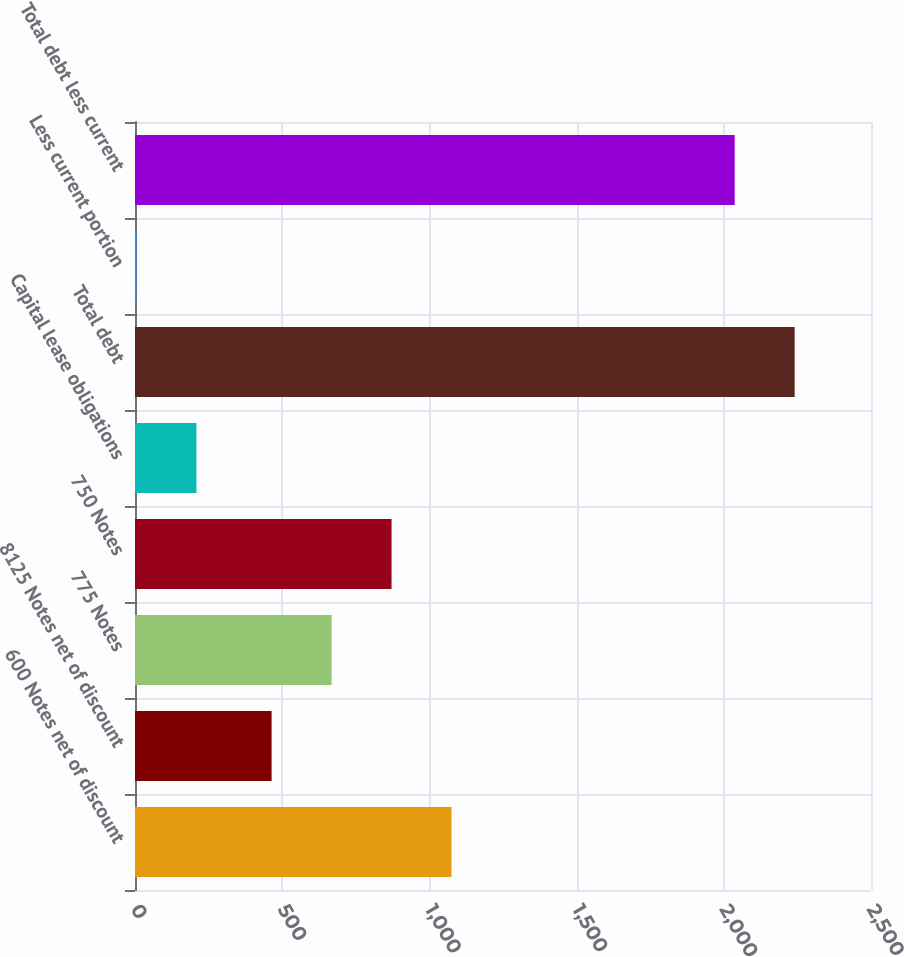Convert chart to OTSL. <chart><loc_0><loc_0><loc_500><loc_500><bar_chart><fcel>600 Notes net of discount<fcel>8125 Notes net of discount<fcel>775 Notes<fcel>750 Notes<fcel>Capital lease obligations<fcel>Total debt<fcel>Less current portion<fcel>Total debt less current<nl><fcel>1075.1<fcel>464<fcel>667.7<fcel>871.4<fcel>208.7<fcel>2240.7<fcel>5<fcel>2037<nl></chart> 